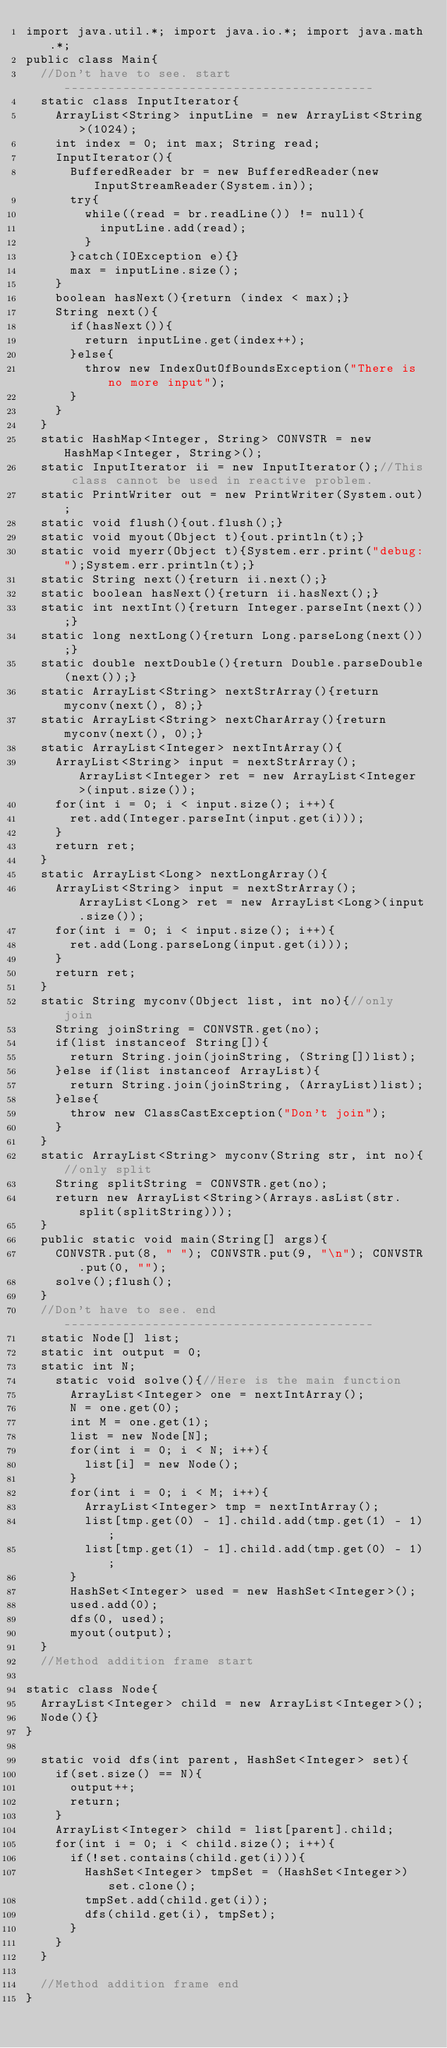<code> <loc_0><loc_0><loc_500><loc_500><_Java_>import java.util.*; import java.io.*; import java.math.*;
public class Main{
	//Don't have to see. start------------------------------------------
	static class InputIterator{
		ArrayList<String> inputLine = new ArrayList<String>(1024);
		int index = 0; int max; String read;
		InputIterator(){
			BufferedReader br = new BufferedReader(new InputStreamReader(System.in));
			try{
				while((read = br.readLine()) != null){
					inputLine.add(read);
				}
			}catch(IOException e){}
			max = inputLine.size();
		}
		boolean hasNext(){return (index < max);}
		String next(){
			if(hasNext()){
				return inputLine.get(index++);
			}else{
				throw new IndexOutOfBoundsException("There is no more input");
			}
		}
	}
	static HashMap<Integer, String> CONVSTR = new HashMap<Integer, String>();
	static InputIterator ii = new InputIterator();//This class cannot be used in reactive problem.
	static PrintWriter out = new PrintWriter(System.out);
	static void flush(){out.flush();}
	static void myout(Object t){out.println(t);}
	static void myerr(Object t){System.err.print("debug:");System.err.println(t);}
	static String next(){return ii.next();}
	static boolean hasNext(){return ii.hasNext();}
	static int nextInt(){return Integer.parseInt(next());}
	static long nextLong(){return Long.parseLong(next());}
	static double nextDouble(){return Double.parseDouble(next());}
	static ArrayList<String> nextStrArray(){return myconv(next(), 8);}
	static ArrayList<String> nextCharArray(){return myconv(next(), 0);}
	static ArrayList<Integer> nextIntArray(){
		ArrayList<String> input = nextStrArray(); ArrayList<Integer> ret = new ArrayList<Integer>(input.size());
		for(int i = 0; i < input.size(); i++){
			ret.add(Integer.parseInt(input.get(i)));
		}
		return ret;
	}
	static ArrayList<Long> nextLongArray(){
		ArrayList<String> input = nextStrArray(); ArrayList<Long> ret = new ArrayList<Long>(input.size());
		for(int i = 0; i < input.size(); i++){
			ret.add(Long.parseLong(input.get(i)));
		}
		return ret;
	}
	static String myconv(Object list, int no){//only join
		String joinString = CONVSTR.get(no);
		if(list instanceof String[]){
			return String.join(joinString, (String[])list);
		}else if(list instanceof ArrayList){
			return String.join(joinString, (ArrayList)list);
		}else{
			throw new ClassCastException("Don't join");
		}
	}
	static ArrayList<String> myconv(String str, int no){//only split
		String splitString = CONVSTR.get(no);
		return new ArrayList<String>(Arrays.asList(str.split(splitString)));
	}
	public static void main(String[] args){
		CONVSTR.put(8, " "); CONVSTR.put(9, "\n"); CONVSTR.put(0, "");
		solve();flush();
	}
	//Don't have to see. end------------------------------------------
	static Node[] list;
  static int output = 0;
  static int N;
    static void solve(){//Here is the main function
      ArrayList<Integer> one = nextIntArray();
      N = one.get(0);
      int M = one.get(1);
      list = new Node[N];
      for(int i = 0; i < N; i++){
        list[i] = new Node();
      }
      for(int i = 0; i < M; i++){
        ArrayList<Integer> tmp = nextIntArray();
        list[tmp.get(0) - 1].child.add(tmp.get(1) - 1);
        list[tmp.get(1) - 1].child.add(tmp.get(0) - 1);
      }
      HashSet<Integer> used = new HashSet<Integer>();
      used.add(0);
      dfs(0, used);
      myout(output);
	}
	//Method addition frame start

static class Node{
  ArrayList<Integer> child = new ArrayList<Integer>();
  Node(){}
}
  
  static void dfs(int parent, HashSet<Integer> set){
    if(set.size() == N){
      output++;
      return;
    }
    ArrayList<Integer> child = list[parent].child;
    for(int i = 0; i < child.size(); i++){
      if(!set.contains(child.get(i))){
        HashSet<Integer> tmpSet = (HashSet<Integer>)set.clone();
        tmpSet.add(child.get(i));
        dfs(child.get(i), tmpSet);
      }
    }
  }
  
	//Method addition frame end
}
</code> 